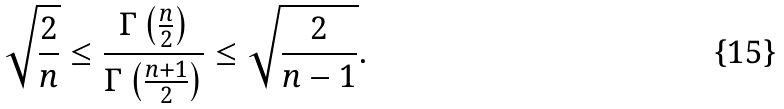<formula> <loc_0><loc_0><loc_500><loc_500>\sqrt { \frac { 2 } { n } } \leq \frac { \Gamma \left ( \frac { n } { 2 } \right ) } { \Gamma \left ( \frac { n + 1 } { 2 } \right ) } \leq \sqrt { \frac { 2 } { n - 1 } } .</formula> 